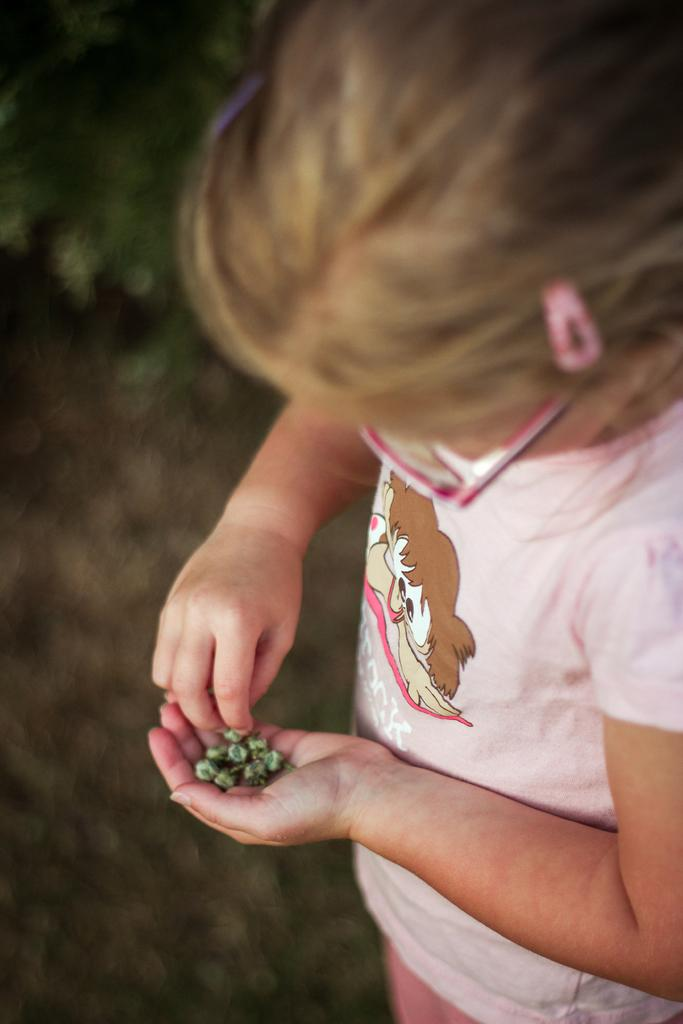Who is the main subject in the image? There is a girl in the image. What is the girl wearing on her face? The girl is wearing spectacles. What type of clothing is the girl wearing? The girl is wearing a dress. What is the girl holding in her hand? The girl is holding objects in her hand. What language is the ghost speaking in the image? There is no ghost present in the image, so it is not possible to determine what language the ghost might be speaking. 